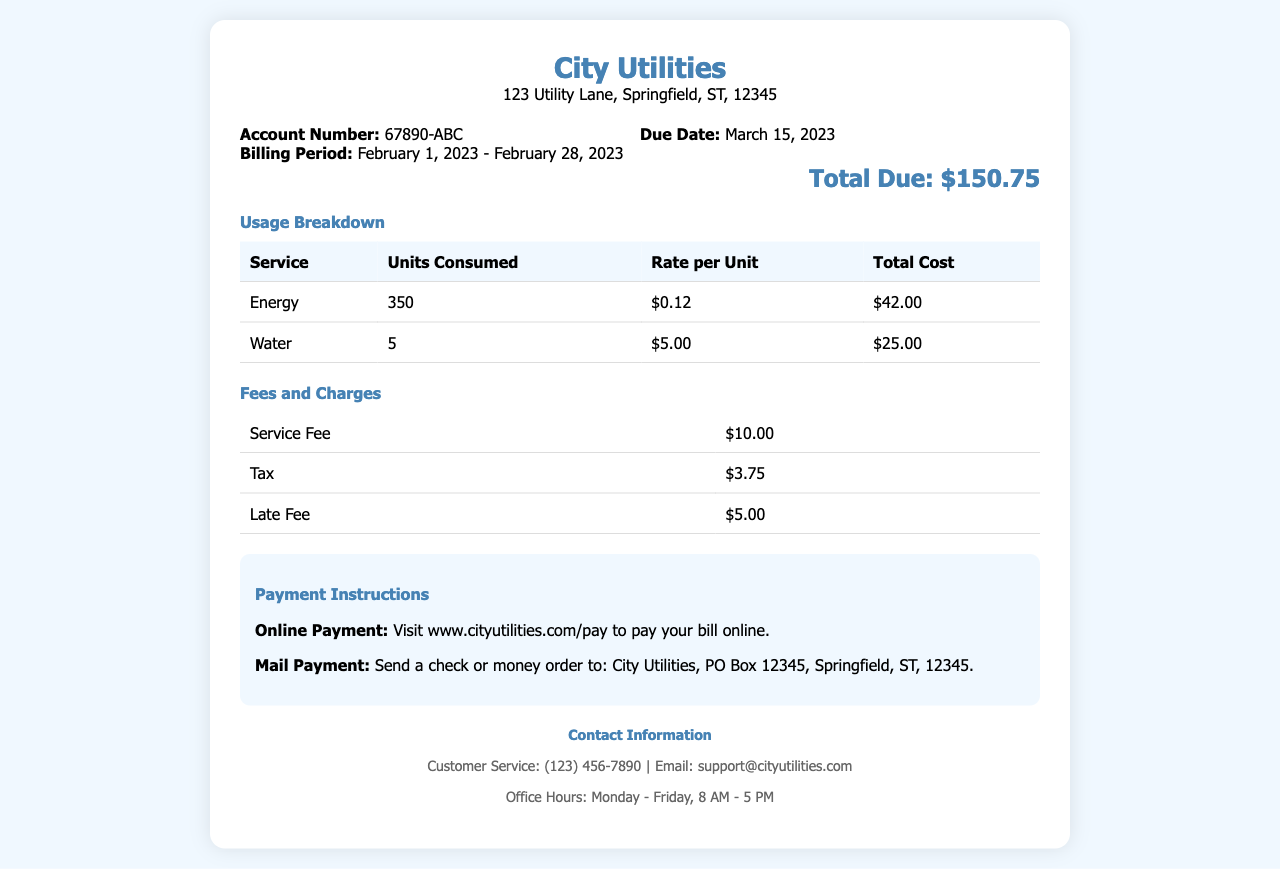What is the billing period? The billing period is specified in the invoice details as February 1, 2023 - February 28, 2023.
Answer: February 1, 2023 - February 28, 2023 What is the account number? The invoice provides the account number, which is listed as 67890-ABC.
Answer: 67890-ABC How much was billed for energy? The total cost for energy usage is provided as $42.00.
Answer: $42.00 What is the due date for this invoice? The due date is indicated in the invoice details as March 15, 2023.
Answer: March 15, 2023 What is the total amount due? The total due amount is stated clearly in the document as $150.75.
Answer: $150.75 How many units of water were consumed? The number of water units consumed is specified in the usage breakdown as 5.
Answer: 5 What is the service fee? The service fee is listed under fees and charges as $10.00.
Answer: $10.00 What would the late fee be if paid after the due date? The late fee mentioned in the document is $5.00.
Answer: $5.00 How can the bill be paid online? The online payment option is provided with a link: www.cityutilities.com/pay.
Answer: www.cityutilities.com/pay 